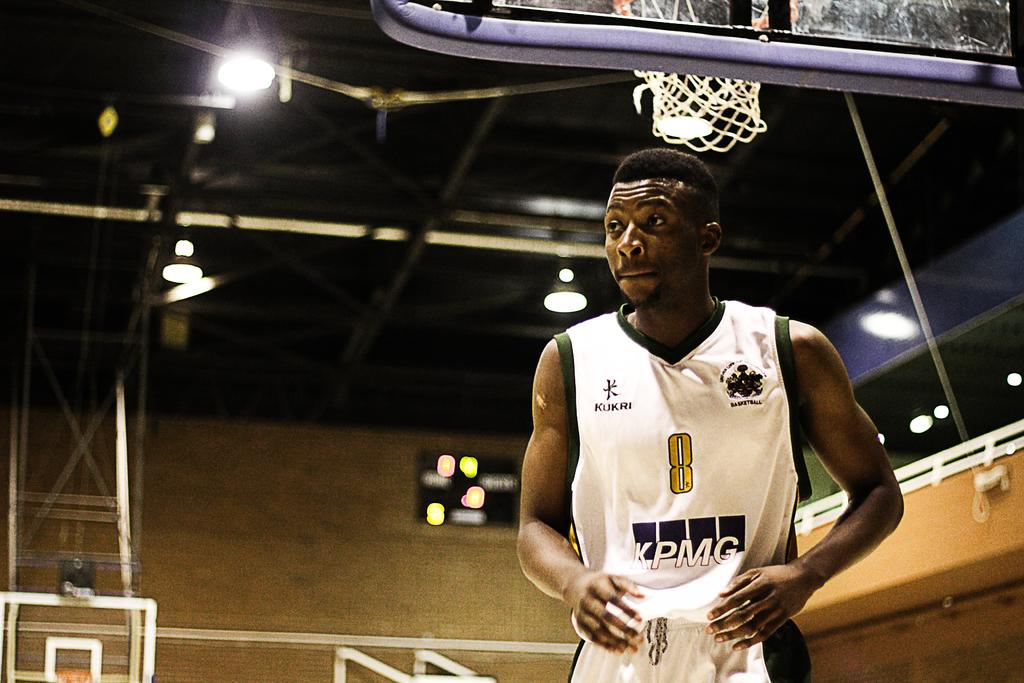<image>
Relay a brief, clear account of the picture shown. A basketball player wearing the number 8 has no one around him. 